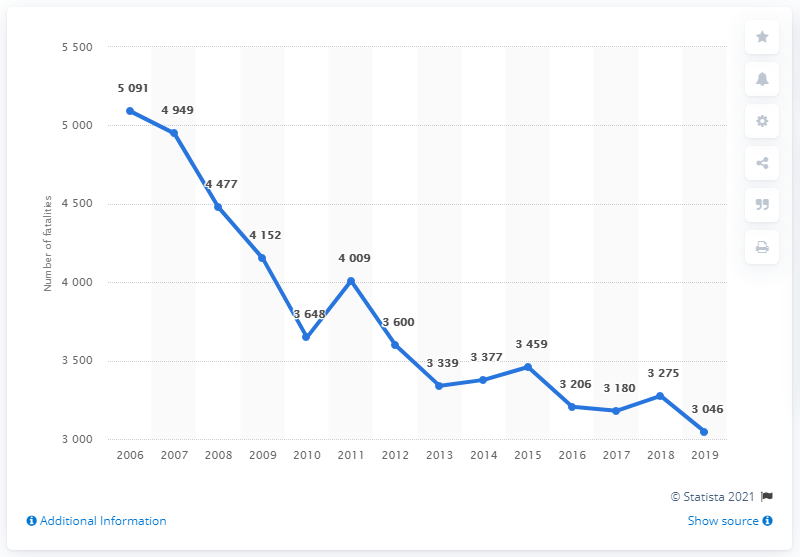Indicate a few pertinent items in this graphic. In the year 2006, the highest number of road fatalities occurred. 